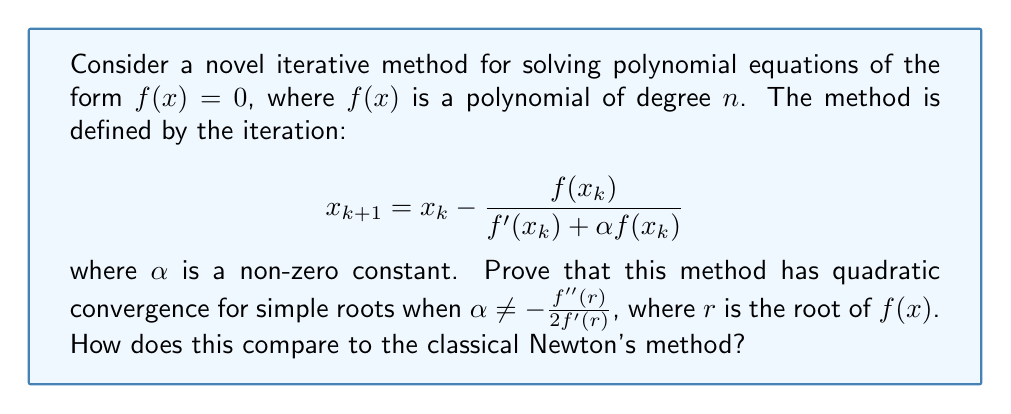Teach me how to tackle this problem. To prove quadratic convergence, we need to show that the error term $e_{k+1}$ is proportional to $e_k^2$, where $e_k = x_k - r$.

Step 1: Taylor expansion of $f(x_k)$ around the root $r$:
$$f(x_k) = f(r) + f'(r)e_k + \frac{1}{2}f''(r)e_k^2 + O(e_k^3)$$

Step 2: Taylor expansion of $f'(x_k)$ around $r$:
$$f'(x_k) = f'(r) + f''(r)e_k + O(e_k^2)$$

Step 3: Substitute these expansions into the iteration formula:
$$\begin{align*}
x_{k+1} &= x_k - \frac{f(x_k)}{f'(x_k) + \alpha f(x_k)} \\
e_{k+1} + r &= e_k + r - \frac{f'(r)e_k + \frac{1}{2}f''(r)e_k^2 + O(e_k^3)}{f'(r) + f''(r)e_k + O(e_k^2) + \alpha(f'(r)e_k + \frac{1}{2}f''(r)e_k^2 + O(e_k^3))}
\end{align*}$$

Step 4: Simplify the denominator:
$$e_{k+1} = e_k - \frac{f'(r)e_k + \frac{1}{2}f''(r)e_k^2 + O(e_k^3)}{f'(r) + (f''(r) + \alpha f'(r))e_k + O(e_k^2)}$$

Step 5: Use the binomial expansion $(1+x)^{-1} = 1 - x + x^2 - \cdots$ to expand the fraction:
$$\begin{align*}
e_{k+1} &= e_k - \left(e_k + \frac{1}{2}\frac{f''(r)}{f'(r)}e_k^2\right)\left(1 - \frac{f''(r) + \alpha f'(r)}{f'(r)}e_k + O(e_k^2)\right) \\
&= e_k - e_k - \frac{1}{2}\frac{f''(r)}{f'(r)}e_k^2 + \frac{f''(r) + \alpha f'(r)}{f'(r)}e_k^2 + O(e_k^3) \\
&= \left(\frac{f''(r) + \alpha f'(r)}{f'(r)} - \frac{1}{2}\frac{f''(r)}{f'(r)}\right)e_k^2 + O(e_k^3) \\
&= \left(\frac{1}{2}\frac{f''(r)}{f'(r)} + \alpha\right)e_k^2 + O(e_k^3)
\end{align*}$$

Step 6: The coefficient of $e_k^2$ is non-zero when $\alpha \neq -\frac{f''(r)}{2f'(r)}$, proving quadratic convergence.

Comparison to Newton's method:
Newton's method has the iteration formula $x_{k+1} = x_k - \frac{f(x_k)}{f'(x_k)}$, which is equivalent to setting $\alpha = 0$ in our novel method. Both methods have quadratic convergence, but the novel method allows for potential optimization by choosing $\alpha$ to minimize the error coefficient.
Answer: Quadratic convergence when $\alpha \neq -\frac{f''(r)}{2f'(r)}$ 